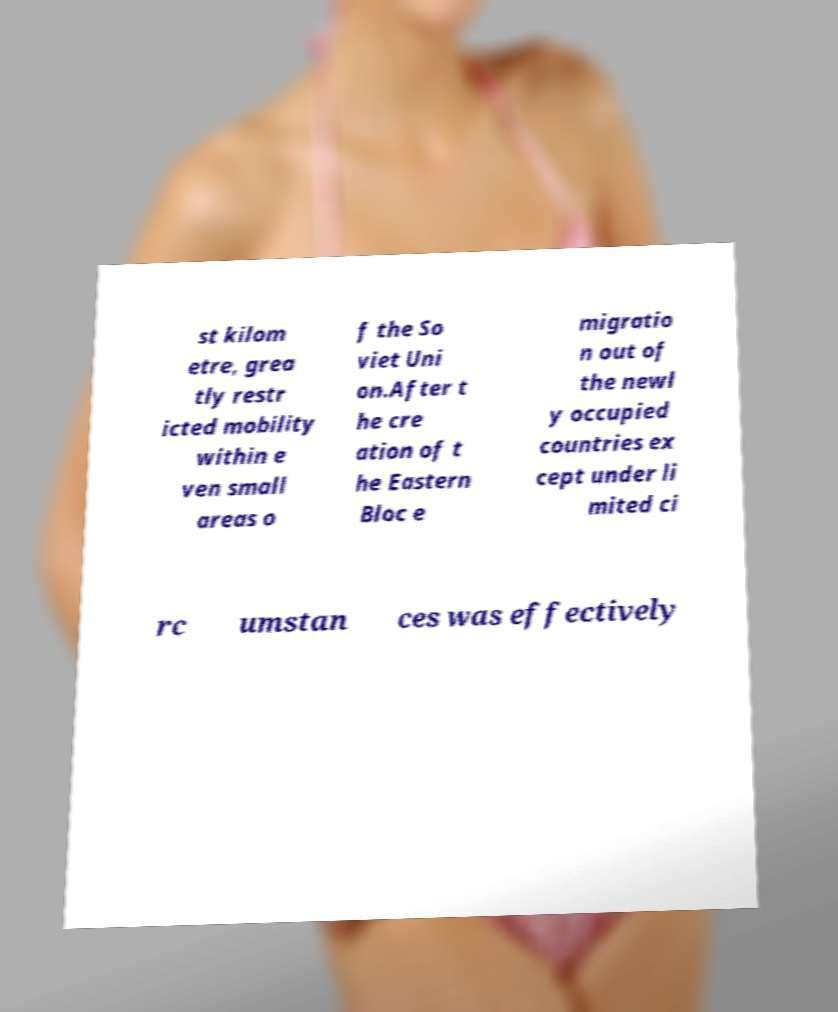Could you assist in decoding the text presented in this image and type it out clearly? st kilom etre, grea tly restr icted mobility within e ven small areas o f the So viet Uni on.After t he cre ation of t he Eastern Bloc e migratio n out of the newl y occupied countries ex cept under li mited ci rc umstan ces was effectively 